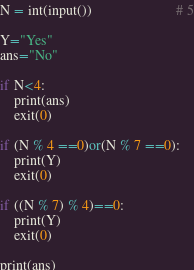<code> <loc_0><loc_0><loc_500><loc_500><_Python_>N = int(input())						# 5

Y="Yes"
ans="No"

if N<4:
	print(ans)
	exit(0)

if (N % 4 ==0)or(N % 7 ==0):
	print(Y)
	exit(0)

if ((N % 7) % 4)==0:
	print(Y)
	exit(0)

print(ans)
</code> 